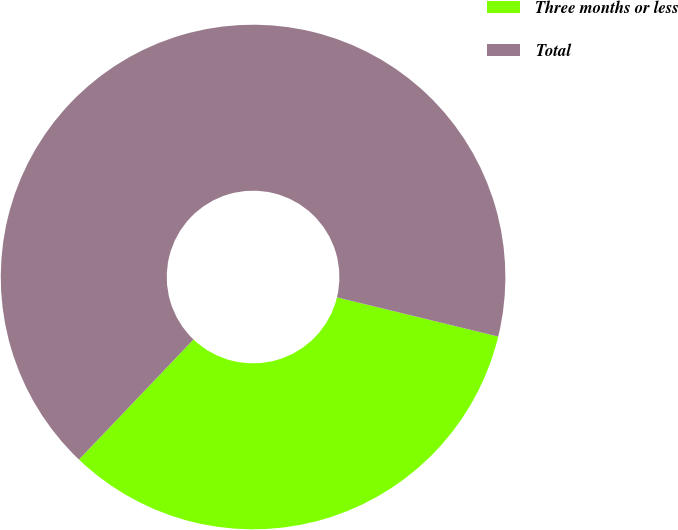Convert chart to OTSL. <chart><loc_0><loc_0><loc_500><loc_500><pie_chart><fcel>Three months or less<fcel>Total<nl><fcel>33.33%<fcel>66.67%<nl></chart> 